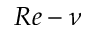Convert formula to latex. <formula><loc_0><loc_0><loc_500><loc_500>R e - \nu</formula> 